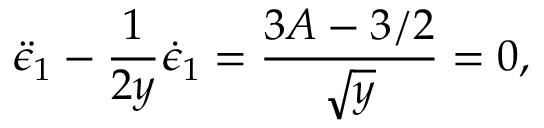<formula> <loc_0><loc_0><loc_500><loc_500>\ddot { \epsilon } _ { 1 } - \frac { 1 } { 2 y } \dot { \epsilon } _ { 1 } = \frac { 3 A - 3 / 2 } { \sqrt { y } } = 0 ,</formula> 